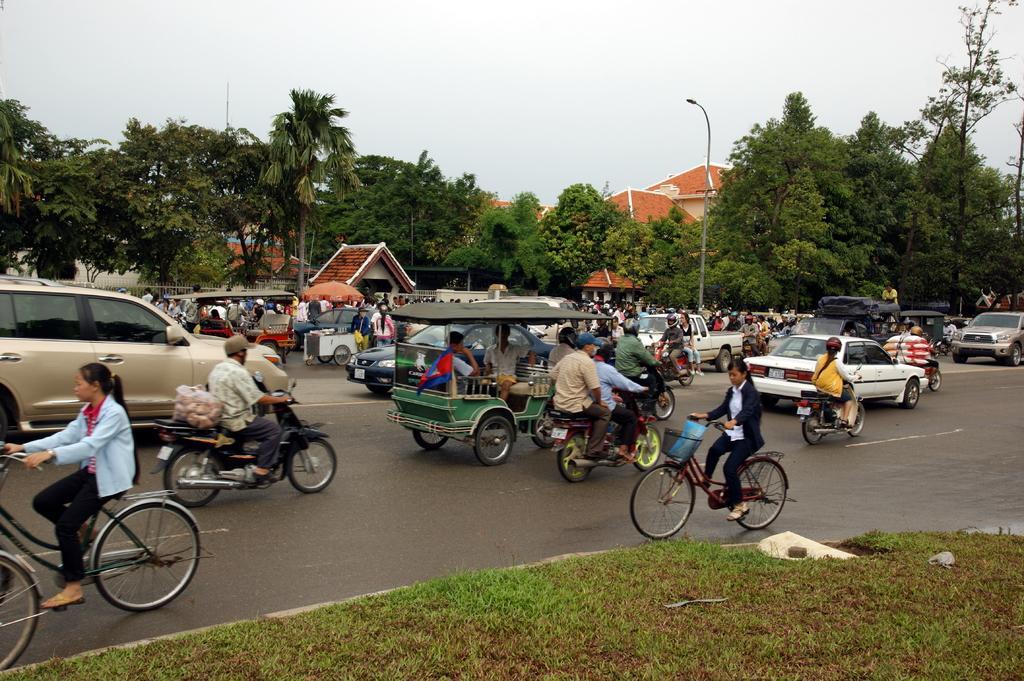Can you describe this image briefly? The picture is clicked on a road where there are several people riding motor vehicles , cars and bicycles. In the background we observe many trees and buildings. 